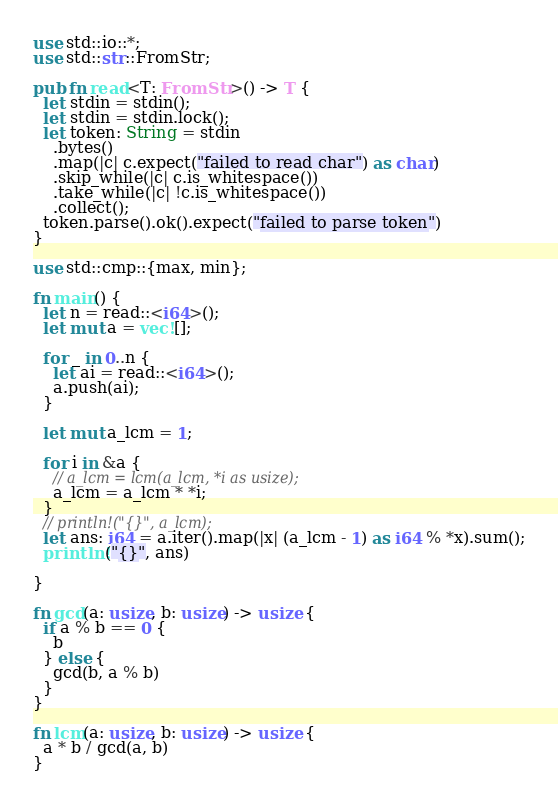Convert code to text. <code><loc_0><loc_0><loc_500><loc_500><_Rust_>
use std::io::*;
use std::str::FromStr;

pub fn read<T: FromStr>() -> T {
  let stdin = stdin();
  let stdin = stdin.lock();
  let token: String = stdin
    .bytes()
    .map(|c| c.expect("failed to read char") as char)
    .skip_while(|c| c.is_whitespace())
    .take_while(|c| !c.is_whitespace())
    .collect();
  token.parse().ok().expect("failed to parse token")
}

use std::cmp::{max, min};

fn main() {
  let n = read::<i64>();
  let mut a = vec![];

  for _ in 0..n {
    let ai = read::<i64>();
    a.push(ai);
  }

  let mut a_lcm = 1;

  for i in &a {
    // a_lcm = lcm(a_lcm, *i as usize);
    a_lcm = a_lcm * *i;
  }
  // println!("{}", a_lcm);
  let ans: i64 = a.iter().map(|x| (a_lcm - 1) as i64 % *x).sum();
  println!("{}", ans)

}

fn gcd(a: usize, b: usize) -> usize {
  if a % b == 0 {
    b
  } else {
    gcd(b, a % b)
  }
}

fn lcm(a: usize, b: usize) -> usize {
  a * b / gcd(a, b)
}

</code> 